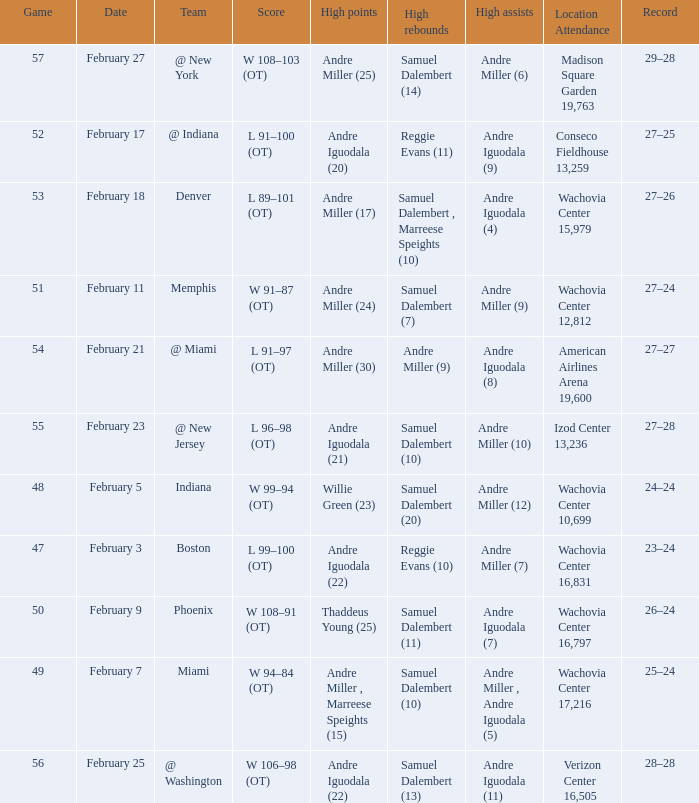When did they play Miami? February 7. 